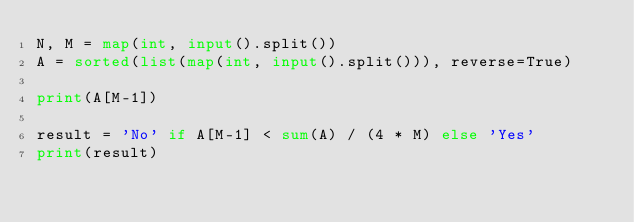Convert code to text. <code><loc_0><loc_0><loc_500><loc_500><_Python_>N, M = map(int, input().split())
A = sorted(list(map(int, input().split())), reverse=True)

print(A[M-1])

result = 'No' if A[M-1] < sum(A) / (4 * M) else 'Yes'
print(result)
</code> 